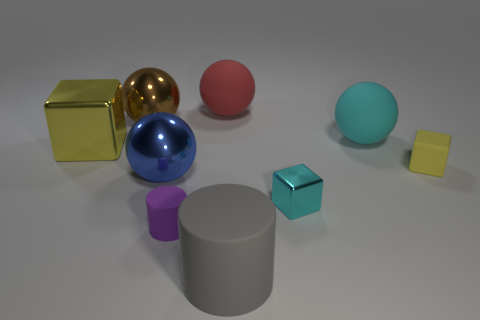Subtract 1 spheres. How many spheres are left? 3 Add 1 tiny shiny things. How many objects exist? 10 Subtract all cylinders. How many objects are left? 7 Subtract all big gray objects. Subtract all large cyan spheres. How many objects are left? 7 Add 3 rubber cubes. How many rubber cubes are left? 4 Add 8 rubber balls. How many rubber balls exist? 10 Subtract 1 blue spheres. How many objects are left? 8 